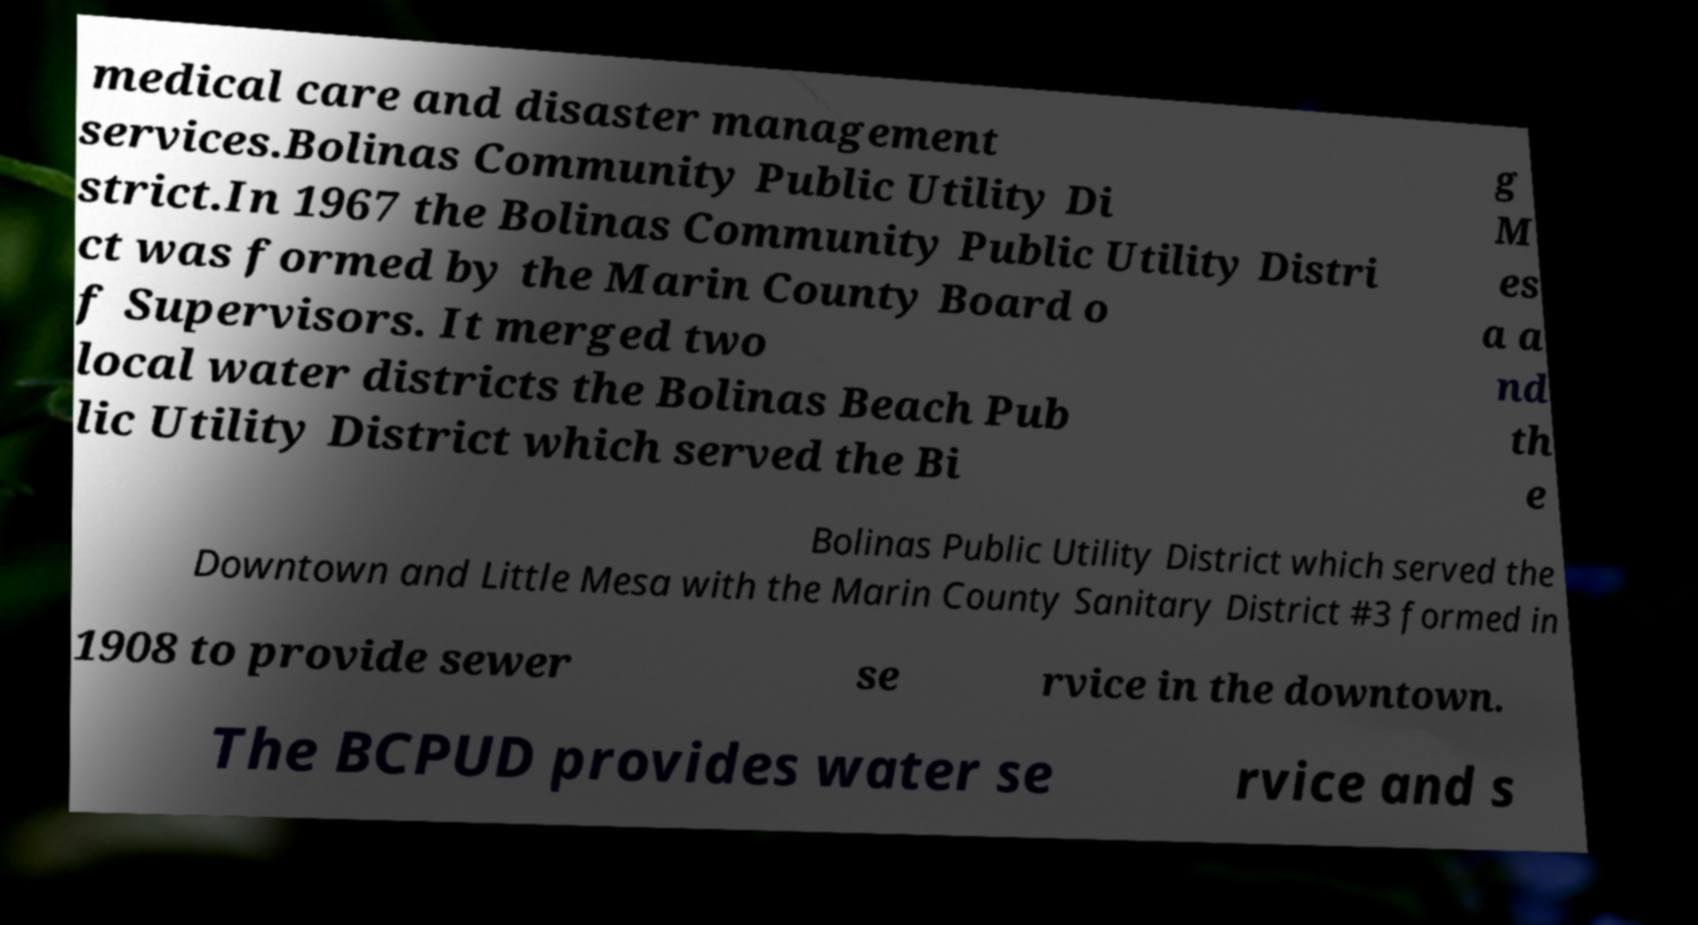Please read and relay the text visible in this image. What does it say? medical care and disaster management services.Bolinas Community Public Utility Di strict.In 1967 the Bolinas Community Public Utility Distri ct was formed by the Marin County Board o f Supervisors. It merged two local water districts the Bolinas Beach Pub lic Utility District which served the Bi g M es a a nd th e Bolinas Public Utility District which served the Downtown and Little Mesa with the Marin County Sanitary District #3 formed in 1908 to provide sewer se rvice in the downtown. The BCPUD provides water se rvice and s 